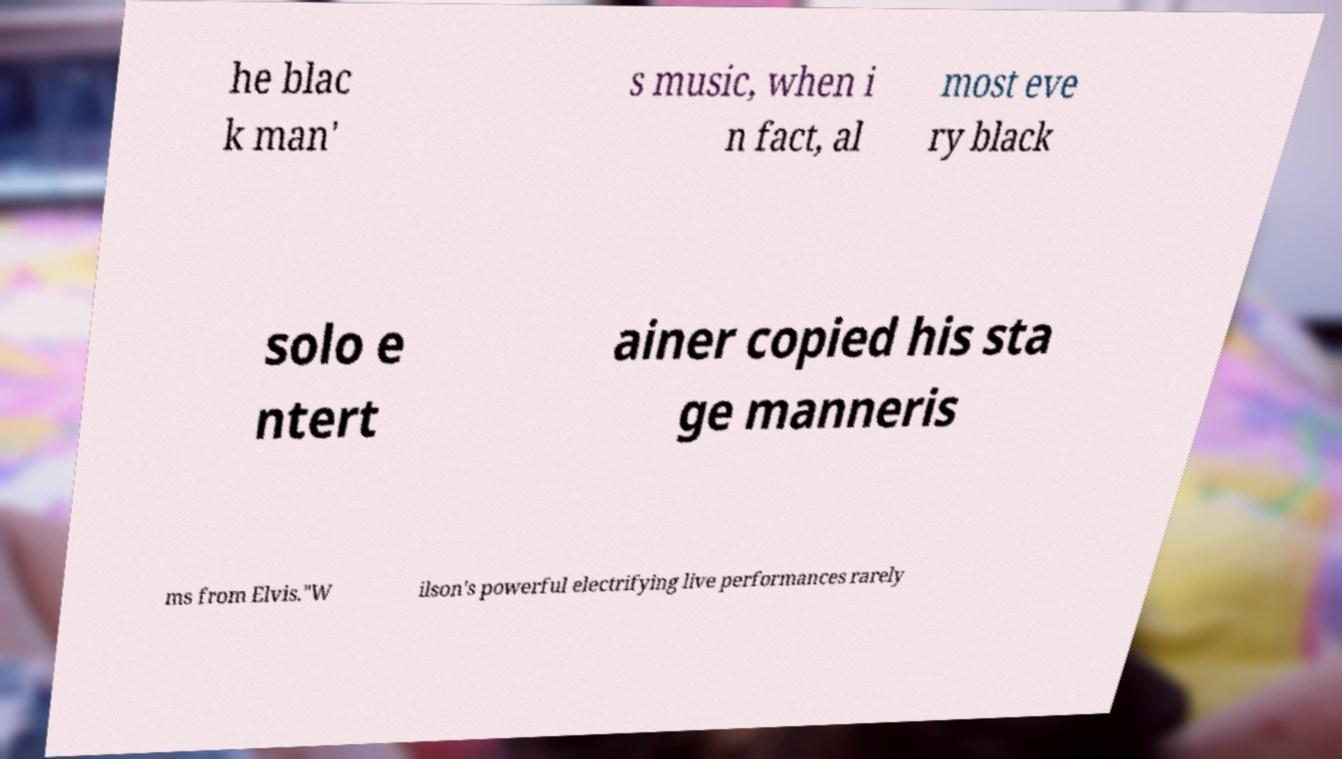For documentation purposes, I need the text within this image transcribed. Could you provide that? he blac k man' s music, when i n fact, al most eve ry black solo e ntert ainer copied his sta ge manneris ms from Elvis."W ilson's powerful electrifying live performances rarely 